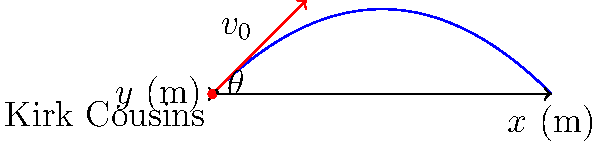As Kirk Cousins prepares to launch a game-winning Hail Mary pass, he throws the football with an initial velocity of 25 m/s at a 45-degree angle. Assuming no air resistance, what is the maximum height reached by the football during its flight? To find the maximum height of the football, we'll follow these steps:

1) The vertical component of the initial velocity is:
   $v_{0y} = v_0 \sin \theta = 25 \cdot \sin 45° = 25 \cdot \frac{\sqrt{2}}{2} \approx 17.68$ m/s

2) The time to reach the maximum height is when the vertical velocity becomes zero:
   $t_{max} = \frac{v_{0y}}{g} = \frac{17.68}{9.8} \approx 1.80$ seconds

3) The maximum height can be calculated using the equation:
   $y_{max} = v_{0y}t - \frac{1}{2}gt^2$

4) Substituting the values:
   $y_{max} = 17.68 \cdot 1.80 - \frac{1}{2} \cdot 9.8 \cdot 1.80^2$
   $y_{max} = 31.82 - 15.91 = 15.91$ meters

Therefore, the maximum height reached by the football is approximately 15.91 meters.
Answer: 15.91 meters 